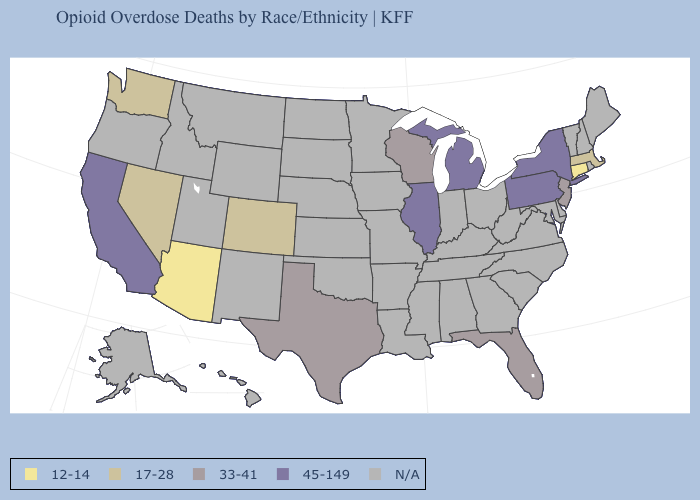Name the states that have a value in the range N/A?
Answer briefly. Alabama, Alaska, Arkansas, Delaware, Georgia, Hawaii, Idaho, Indiana, Iowa, Kansas, Kentucky, Louisiana, Maine, Maryland, Minnesota, Mississippi, Missouri, Montana, Nebraska, New Hampshire, New Mexico, North Carolina, North Dakota, Ohio, Oklahoma, Oregon, Rhode Island, South Carolina, South Dakota, Tennessee, Utah, Vermont, Virginia, West Virginia, Wyoming. What is the value of New Jersey?
Quick response, please. 33-41. What is the value of South Carolina?
Keep it brief. N/A. Does New Jersey have the lowest value in the Northeast?
Be succinct. No. What is the highest value in states that border Pennsylvania?
Write a very short answer. 45-149. What is the value of Nevada?
Give a very brief answer. 17-28. Name the states that have a value in the range 45-149?
Keep it brief. California, Illinois, Michigan, New York, Pennsylvania. What is the lowest value in the USA?
Keep it brief. 12-14. What is the value of North Carolina?
Be succinct. N/A. Does the map have missing data?
Be succinct. Yes. Name the states that have a value in the range 12-14?
Write a very short answer. Arizona, Connecticut. What is the lowest value in the MidWest?
Short answer required. 33-41. Name the states that have a value in the range 33-41?
Keep it brief. Florida, New Jersey, Texas, Wisconsin. 